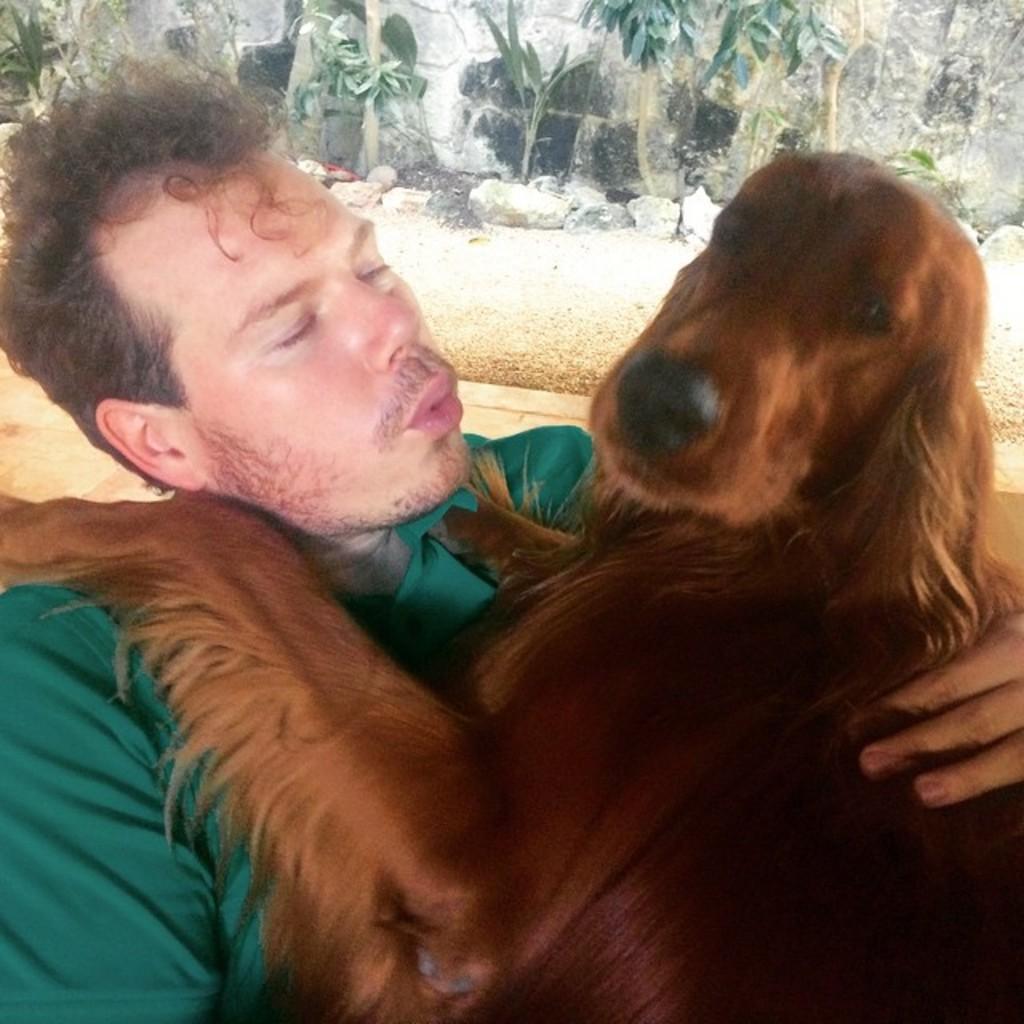Describe this image in one or two sentences. In this image the person is holding the dog and he is wearing the green shirt and background is very sunny behind the person some trees are there. 